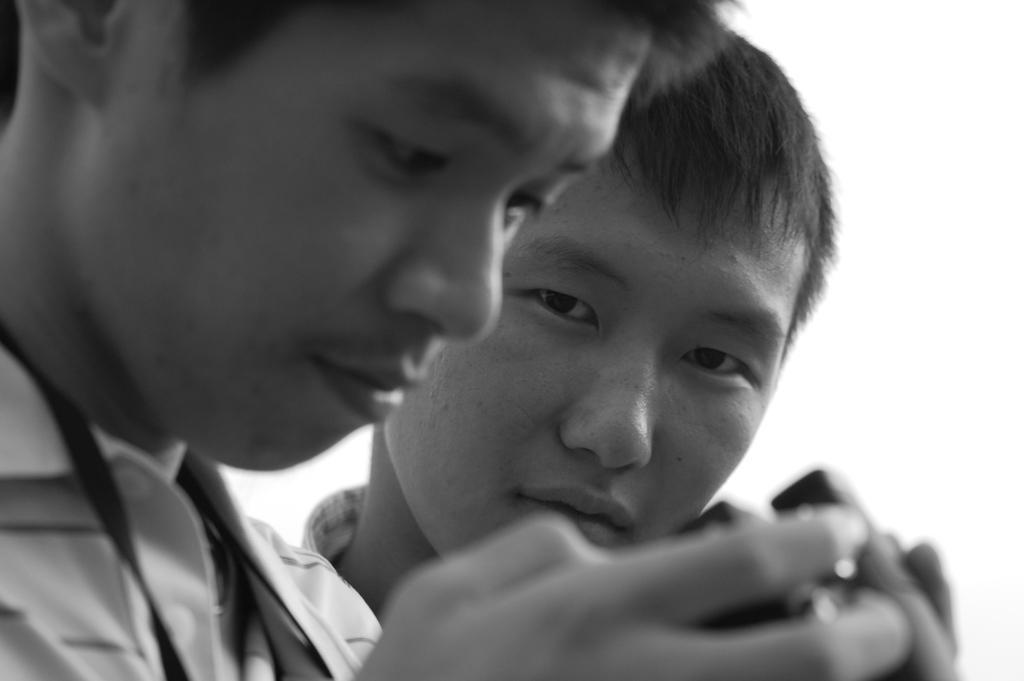Could you give a brief overview of what you see in this image? It is a black and white image, on the left side a boy is looking at this camera, beside him another boy is looking at this side. 